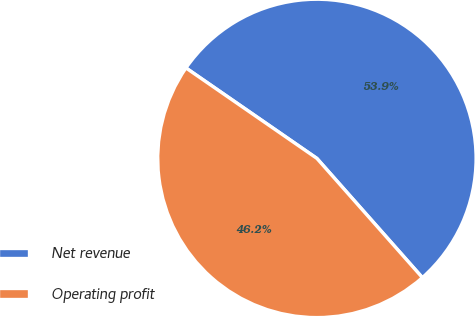Convert chart to OTSL. <chart><loc_0><loc_0><loc_500><loc_500><pie_chart><fcel>Net revenue<fcel>Operating profit<nl><fcel>53.85%<fcel>46.15%<nl></chart> 